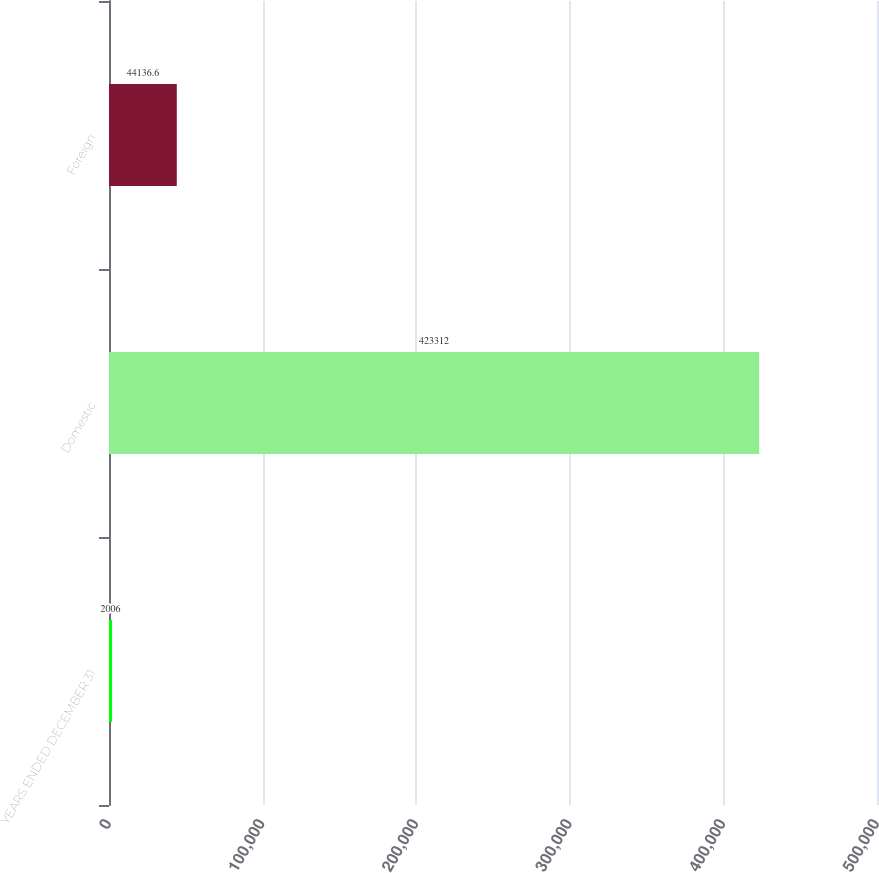Convert chart. <chart><loc_0><loc_0><loc_500><loc_500><bar_chart><fcel>YEARS ENDED DECEMBER 31<fcel>Domestic<fcel>Foreign<nl><fcel>2006<fcel>423312<fcel>44136.6<nl></chart> 